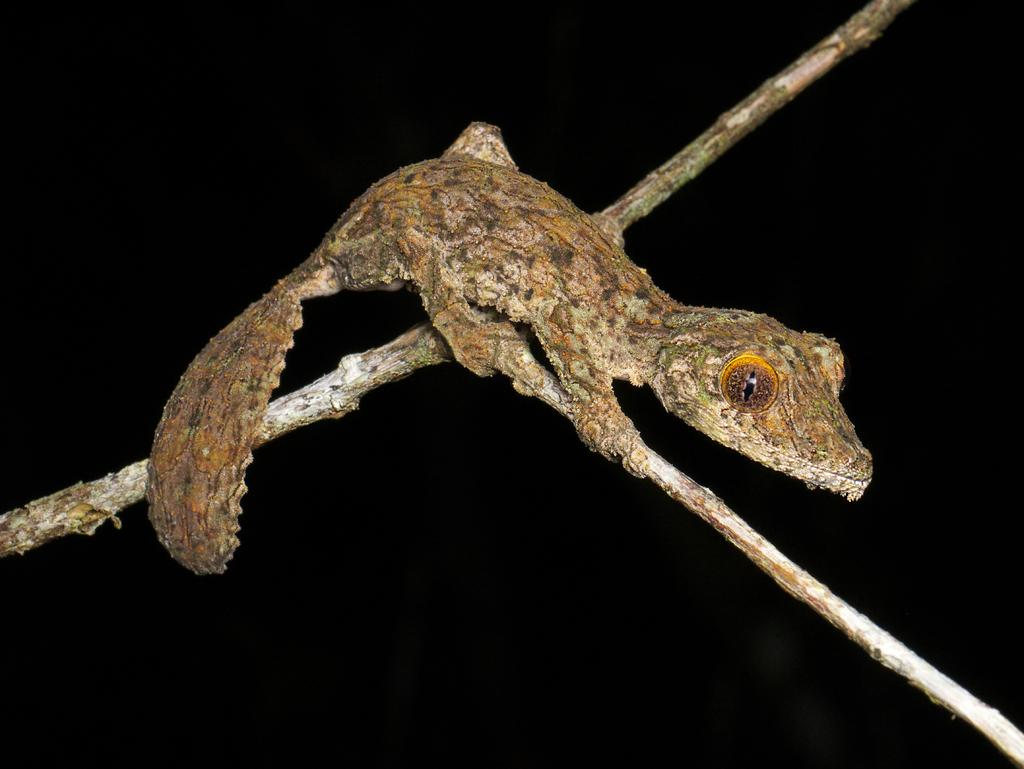What type of animal is in the picture? There is a lizard in the picture. What are some features of the lizard? The lizard has eyes, a body, and a tail. Where is the lizard located in the image? The lizard is sitting on a stem. What is the color of the backdrop in the image? The backdrop of the image is dark. What type of leather can be seen on the lizard's lip in the image? There is no leather or lip present on the lizard in the image. The lizard has eyes, a body, and a tail, but no mention of a lip or leather. 